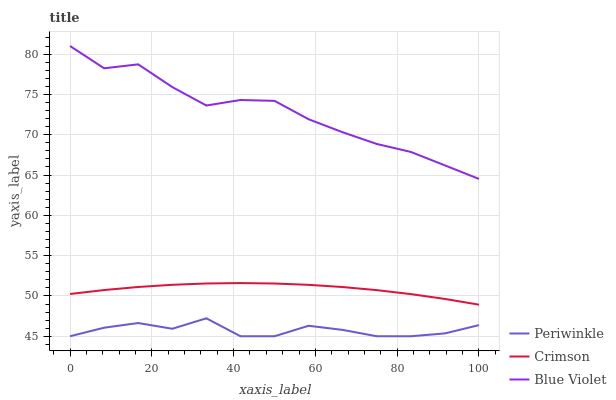Does Periwinkle have the minimum area under the curve?
Answer yes or no. Yes. Does Blue Violet have the maximum area under the curve?
Answer yes or no. Yes. Does Blue Violet have the minimum area under the curve?
Answer yes or no. No. Does Periwinkle have the maximum area under the curve?
Answer yes or no. No. Is Crimson the smoothest?
Answer yes or no. Yes. Is Blue Violet the roughest?
Answer yes or no. Yes. Is Periwinkle the smoothest?
Answer yes or no. No. Is Periwinkle the roughest?
Answer yes or no. No. Does Periwinkle have the lowest value?
Answer yes or no. Yes. Does Blue Violet have the lowest value?
Answer yes or no. No. Does Blue Violet have the highest value?
Answer yes or no. Yes. Does Periwinkle have the highest value?
Answer yes or no. No. Is Periwinkle less than Crimson?
Answer yes or no. Yes. Is Blue Violet greater than Crimson?
Answer yes or no. Yes. Does Periwinkle intersect Crimson?
Answer yes or no. No. 